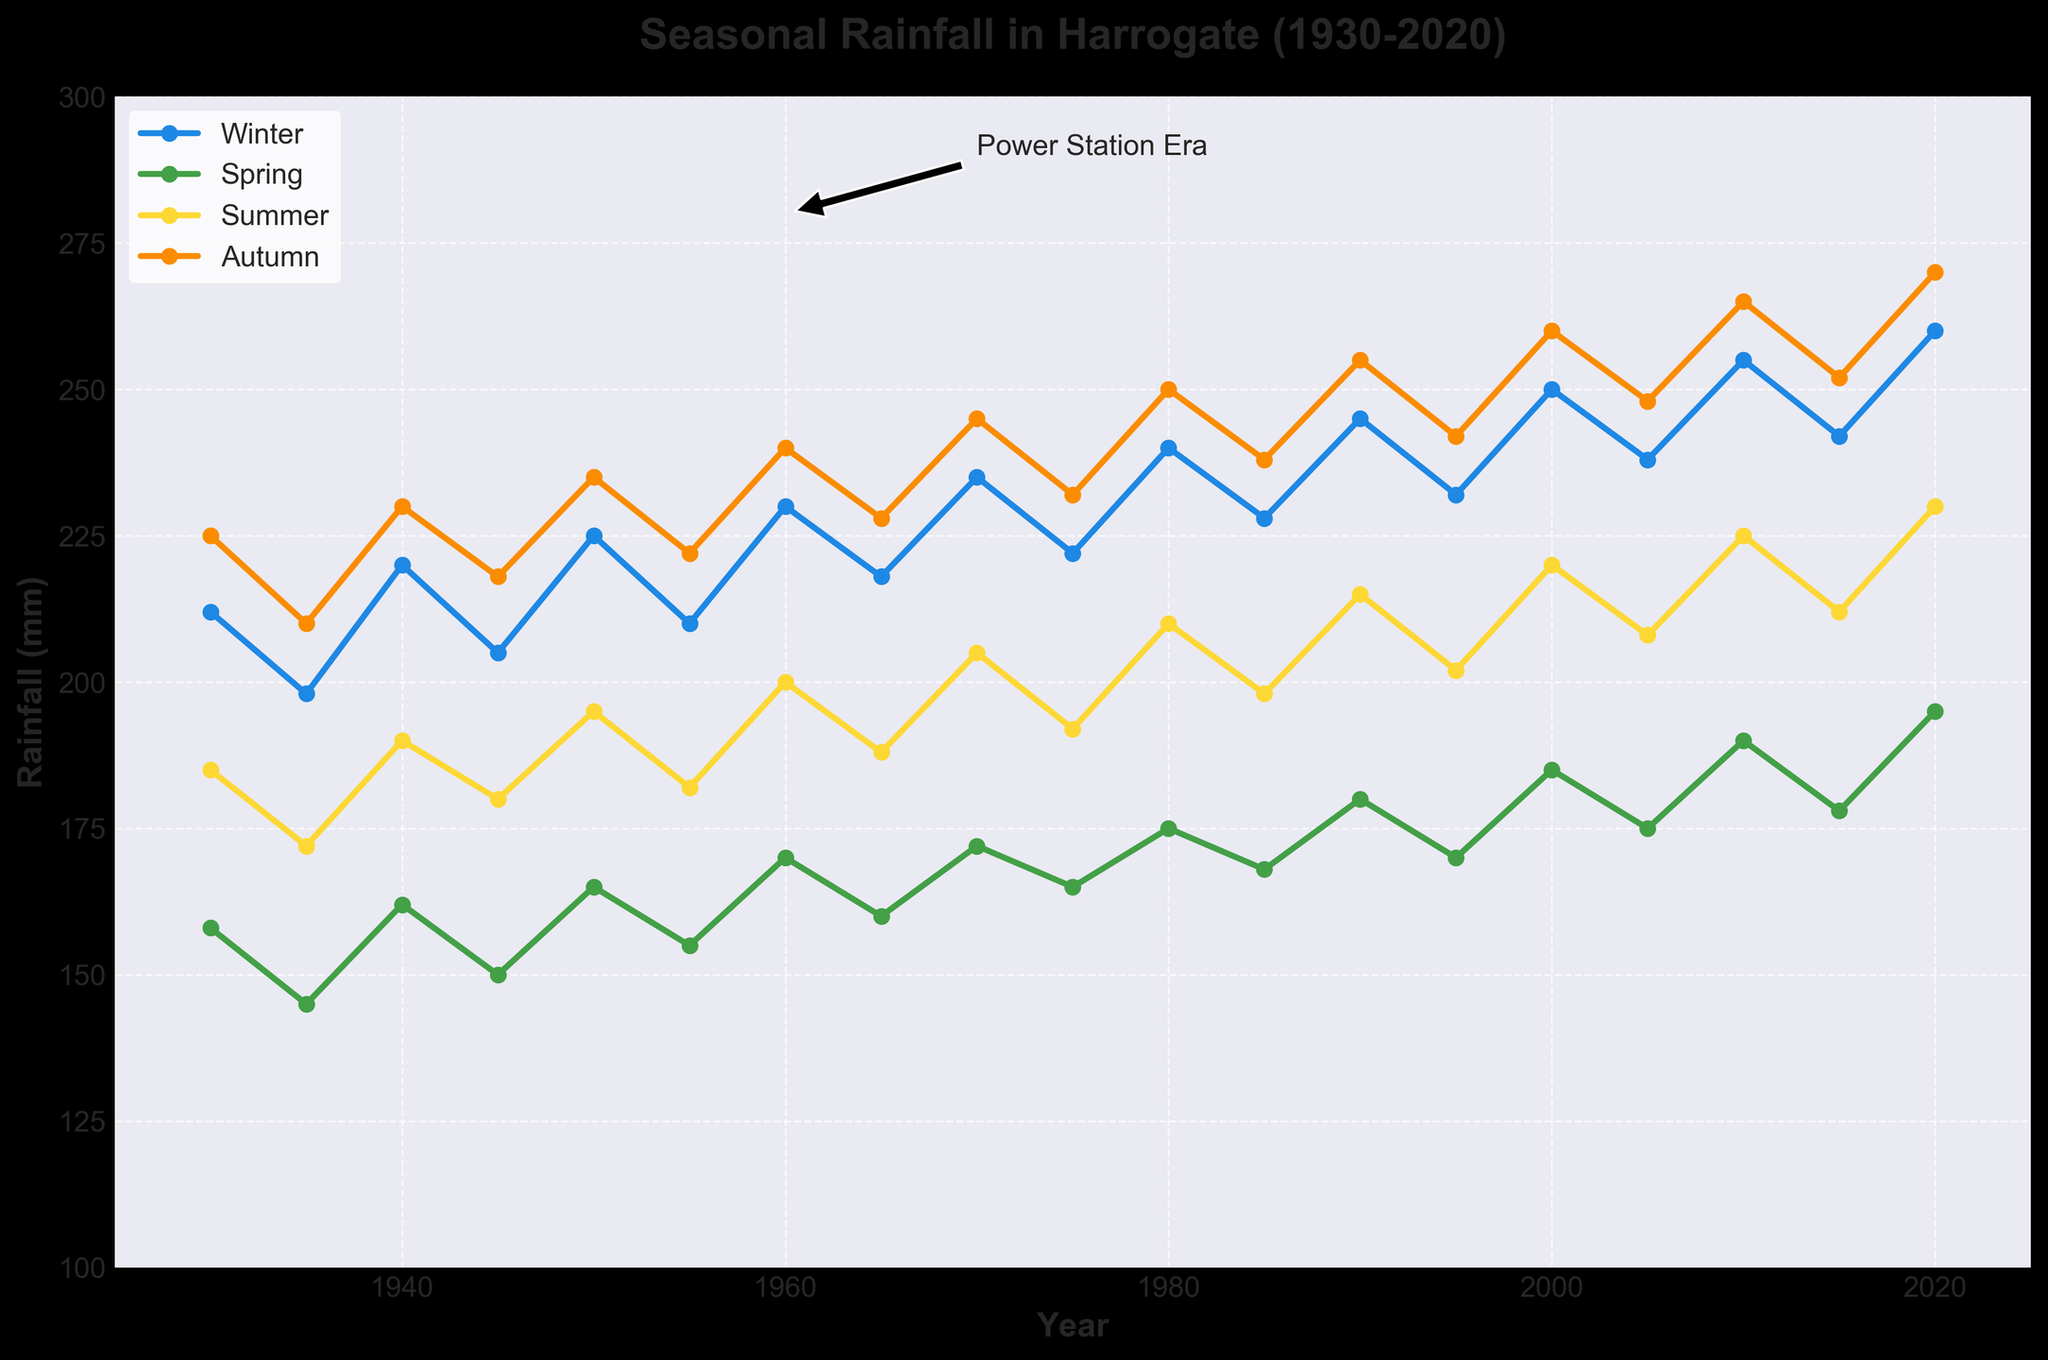What was the annual rainfall in Harrogate in 1945? Looking at the data for the year 1945 in the figure, the annual rainfall amount is provided.
Answer: 753 mm Which season had the highest rainfall in 1980? Observing the different seasonal lines for the year 1980, the label with the highest value is 'Autumn'.
Answer: Autumn By how much did the summer rainfall increase from 1930 to 2020? Calculating the difference between summer rainfall in 2020 (230 mm) and in 1930 (185 mm), we get 230 - 185 = 45 mm.
Answer: 45 mm Compare the total rainfall in 1970 and 2010. Which year was wetter? Comparing the annual rainfall in 1970 (857 mm) and 2010 (935 mm), 2010 had higher rainfall.
Answer: 2010 What is the average winter rainfall over the entire period? By summing winter rainfall data and dividing by the number of years: (212+198+220+205+225+210+230+218+235+222+240+228+245+232+250+238+255+242+260)/18 ≈ 228.17 mm.
Answer: 228.17 mm Did spring rainfall consistently increase or decrease from 1930 to 2020? Checking the values of spring rainfall from 1930 (158 mm) up to 2020 (195 mm), it's clear that it generally increased with some fluctuations.
Answer: Increased with fluctuations During which decade did Harrogate experience the highest average autumn rainfall? Calculating the decade average for autumn rainfall, the decade from 2010 to 2020 has the highest average (258.5 mm).
Answer: 2010-2020 How did winter rainfall in 1995 compare to winter rainfall in 2020? Comparing winter rainfall in 1995 (232 mm) and 2020 (260 mm), the latter had more rainfall.
Answer: 2020 had more What is the difference between the highest and lowest annual rainfalls during the period? The highest annual rainfall is in 2020 (955 mm), and the lowest is in 1935 (725 mm). The difference is 955 - 725 = 230 mm.
Answer: 230 mm What season saw the most variable rainfall over the given years? By visually comparing the spread of data points for each season, Summer appears to show the most variability, with values ranging from 172 mm to 230 mm.
Answer: Summer 